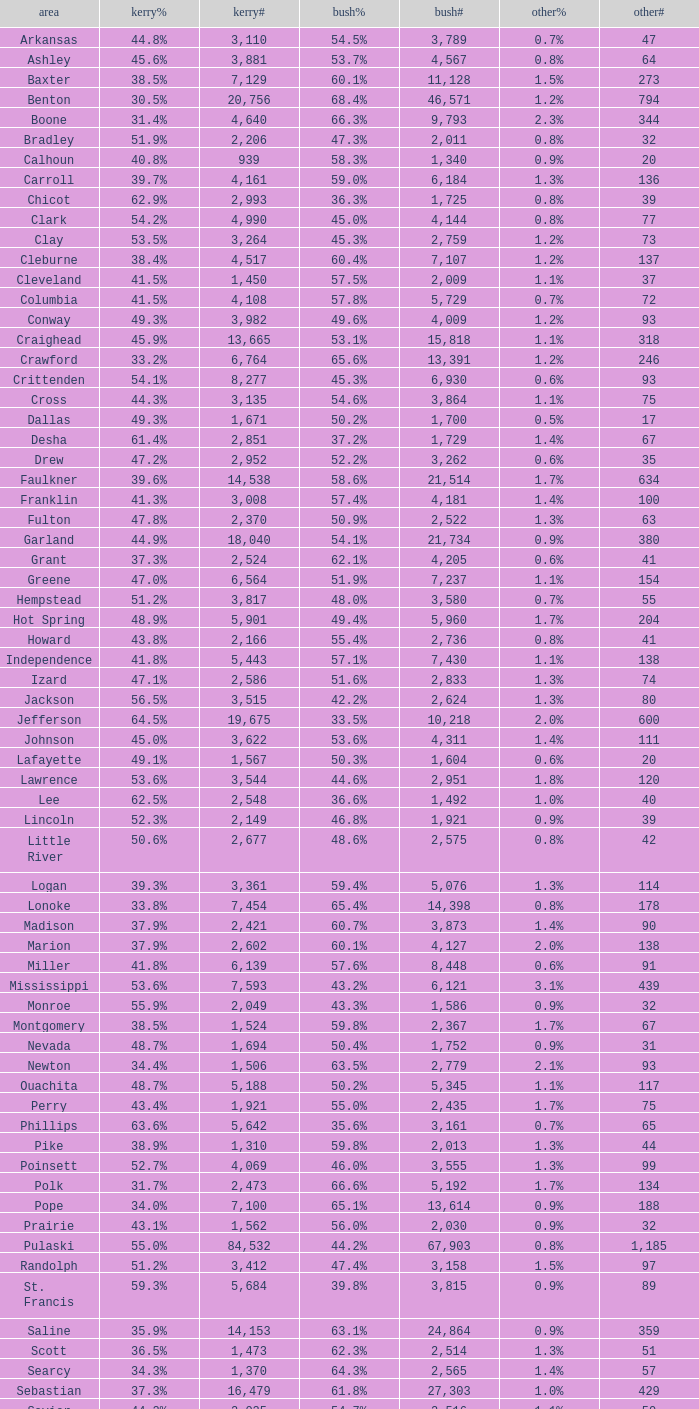Could you parse the entire table as a dict? {'header': ['area', 'kerry%', 'kerry#', 'bush%', 'bush#', 'other%', 'other#'], 'rows': [['Arkansas', '44.8%', '3,110', '54.5%', '3,789', '0.7%', '47'], ['Ashley', '45.6%', '3,881', '53.7%', '4,567', '0.8%', '64'], ['Baxter', '38.5%', '7,129', '60.1%', '11,128', '1.5%', '273'], ['Benton', '30.5%', '20,756', '68.4%', '46,571', '1.2%', '794'], ['Boone', '31.4%', '4,640', '66.3%', '9,793', '2.3%', '344'], ['Bradley', '51.9%', '2,206', '47.3%', '2,011', '0.8%', '32'], ['Calhoun', '40.8%', '939', '58.3%', '1,340', '0.9%', '20'], ['Carroll', '39.7%', '4,161', '59.0%', '6,184', '1.3%', '136'], ['Chicot', '62.9%', '2,993', '36.3%', '1,725', '0.8%', '39'], ['Clark', '54.2%', '4,990', '45.0%', '4,144', '0.8%', '77'], ['Clay', '53.5%', '3,264', '45.3%', '2,759', '1.2%', '73'], ['Cleburne', '38.4%', '4,517', '60.4%', '7,107', '1.2%', '137'], ['Cleveland', '41.5%', '1,450', '57.5%', '2,009', '1.1%', '37'], ['Columbia', '41.5%', '4,108', '57.8%', '5,729', '0.7%', '72'], ['Conway', '49.3%', '3,982', '49.6%', '4,009', '1.2%', '93'], ['Craighead', '45.9%', '13,665', '53.1%', '15,818', '1.1%', '318'], ['Crawford', '33.2%', '6,764', '65.6%', '13,391', '1.2%', '246'], ['Crittenden', '54.1%', '8,277', '45.3%', '6,930', '0.6%', '93'], ['Cross', '44.3%', '3,135', '54.6%', '3,864', '1.1%', '75'], ['Dallas', '49.3%', '1,671', '50.2%', '1,700', '0.5%', '17'], ['Desha', '61.4%', '2,851', '37.2%', '1,729', '1.4%', '67'], ['Drew', '47.2%', '2,952', '52.2%', '3,262', '0.6%', '35'], ['Faulkner', '39.6%', '14,538', '58.6%', '21,514', '1.7%', '634'], ['Franklin', '41.3%', '3,008', '57.4%', '4,181', '1.4%', '100'], ['Fulton', '47.8%', '2,370', '50.9%', '2,522', '1.3%', '63'], ['Garland', '44.9%', '18,040', '54.1%', '21,734', '0.9%', '380'], ['Grant', '37.3%', '2,524', '62.1%', '4,205', '0.6%', '41'], ['Greene', '47.0%', '6,564', '51.9%', '7,237', '1.1%', '154'], ['Hempstead', '51.2%', '3,817', '48.0%', '3,580', '0.7%', '55'], ['Hot Spring', '48.9%', '5,901', '49.4%', '5,960', '1.7%', '204'], ['Howard', '43.8%', '2,166', '55.4%', '2,736', '0.8%', '41'], ['Independence', '41.8%', '5,443', '57.1%', '7,430', '1.1%', '138'], ['Izard', '47.1%', '2,586', '51.6%', '2,833', '1.3%', '74'], ['Jackson', '56.5%', '3,515', '42.2%', '2,624', '1.3%', '80'], ['Jefferson', '64.5%', '19,675', '33.5%', '10,218', '2.0%', '600'], ['Johnson', '45.0%', '3,622', '53.6%', '4,311', '1.4%', '111'], ['Lafayette', '49.1%', '1,567', '50.3%', '1,604', '0.6%', '20'], ['Lawrence', '53.6%', '3,544', '44.6%', '2,951', '1.8%', '120'], ['Lee', '62.5%', '2,548', '36.6%', '1,492', '1.0%', '40'], ['Lincoln', '52.3%', '2,149', '46.8%', '1,921', '0.9%', '39'], ['Little River', '50.6%', '2,677', '48.6%', '2,575', '0.8%', '42'], ['Logan', '39.3%', '3,361', '59.4%', '5,076', '1.3%', '114'], ['Lonoke', '33.8%', '7,454', '65.4%', '14,398', '0.8%', '178'], ['Madison', '37.9%', '2,421', '60.7%', '3,873', '1.4%', '90'], ['Marion', '37.9%', '2,602', '60.1%', '4,127', '2.0%', '138'], ['Miller', '41.8%', '6,139', '57.6%', '8,448', '0.6%', '91'], ['Mississippi', '53.6%', '7,593', '43.2%', '6,121', '3.1%', '439'], ['Monroe', '55.9%', '2,049', '43.3%', '1,586', '0.9%', '32'], ['Montgomery', '38.5%', '1,524', '59.8%', '2,367', '1.7%', '67'], ['Nevada', '48.7%', '1,694', '50.4%', '1,752', '0.9%', '31'], ['Newton', '34.4%', '1,506', '63.5%', '2,779', '2.1%', '93'], ['Ouachita', '48.7%', '5,188', '50.2%', '5,345', '1.1%', '117'], ['Perry', '43.4%', '1,921', '55.0%', '2,435', '1.7%', '75'], ['Phillips', '63.6%', '5,642', '35.6%', '3,161', '0.7%', '65'], ['Pike', '38.9%', '1,310', '59.8%', '2,013', '1.3%', '44'], ['Poinsett', '52.7%', '4,069', '46.0%', '3,555', '1.3%', '99'], ['Polk', '31.7%', '2,473', '66.6%', '5,192', '1.7%', '134'], ['Pope', '34.0%', '7,100', '65.1%', '13,614', '0.9%', '188'], ['Prairie', '43.1%', '1,562', '56.0%', '2,030', '0.9%', '32'], ['Pulaski', '55.0%', '84,532', '44.2%', '67,903', '0.8%', '1,185'], ['Randolph', '51.2%', '3,412', '47.4%', '3,158', '1.5%', '97'], ['St. Francis', '59.3%', '5,684', '39.8%', '3,815', '0.9%', '89'], ['Saline', '35.9%', '14,153', '63.1%', '24,864', '0.9%', '359'], ['Scott', '36.5%', '1,473', '62.3%', '2,514', '1.3%', '51'], ['Searcy', '34.3%', '1,370', '64.3%', '2,565', '1.4%', '57'], ['Sebastian', '37.3%', '16,479', '61.8%', '27,303', '1.0%', '429'], ['Sevier', '44.2%', '2,035', '54.7%', '2,516', '1.1%', '50'], ['Sharp', '43.7%', '3,265', '54.8%', '4,097', '1.4%', '108'], ['Stone', '40.6%', '2,255', '57.5%', '3,188', '1.9%', '106'], ['Union', '39.7%', '7,071', '58.9%', '10,502', '1.5%', '259'], ['Van Buren', '44.9%', '3,310', '54.1%', '3,988', '1.0%', '76'], ['Washington', '43.1%', '27,597', '55.7%', '35,726', '1.2%', '780'], ['White', '34.5%', '9,129', '64.3%', '17,001', '1.1%', '295'], ['Woodruff', '65.2%', '1,972', '33.7%', '1,021', '1.1%', '33'], ['Yell', '43.7%', '2,913', '55.2%', '3,678', '1.0%', '68']]} What is the lowest Kerry#, when Others# is "106", and when Bush# is less than 3,188? None. 